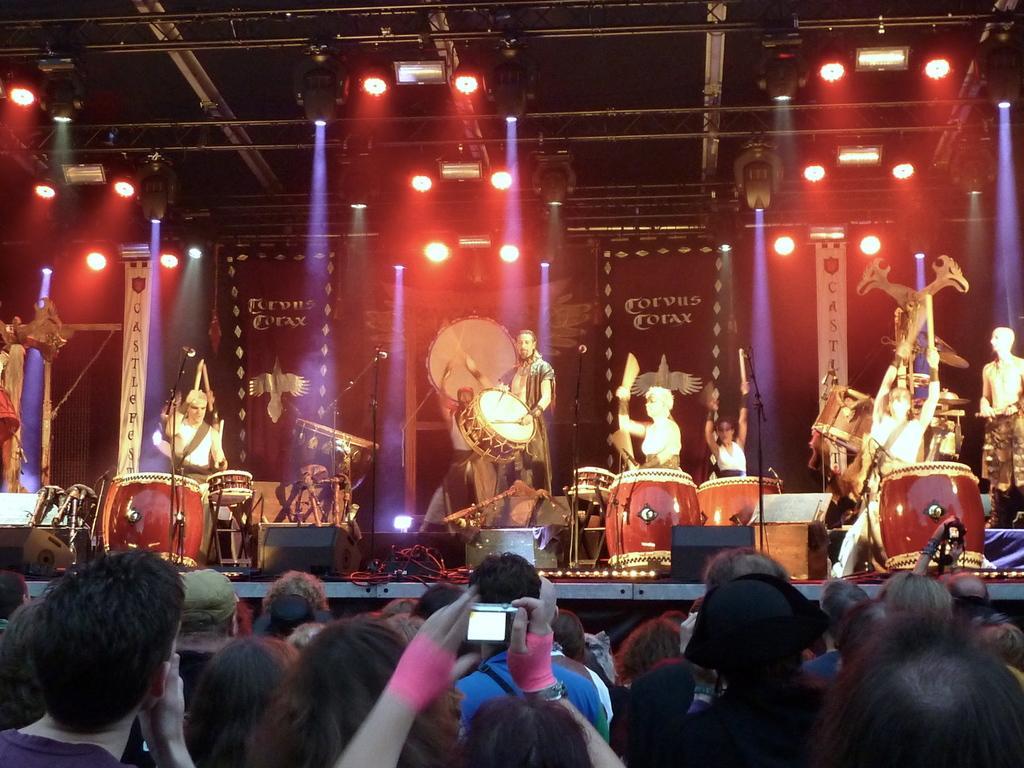Can you describe this image briefly? There is a group of people. They are standing on a stage. They are playing a musical instruments. In the center we have a person. He is holding a camera. We can see in background curtain ,banner and lights. 